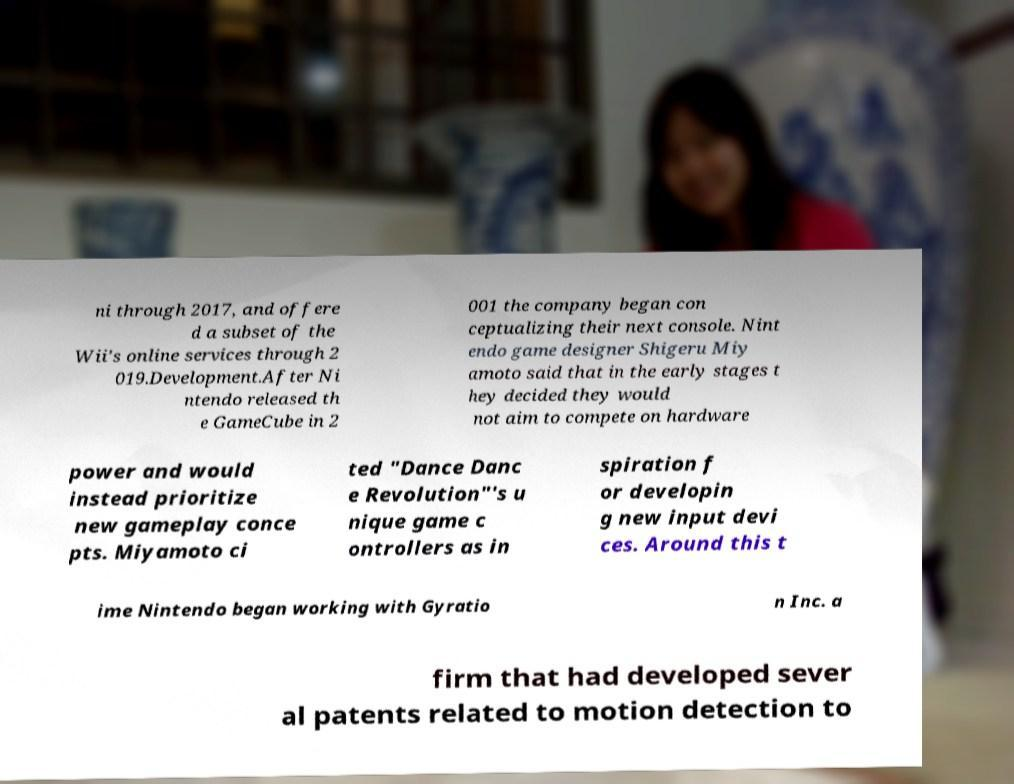There's text embedded in this image that I need extracted. Can you transcribe it verbatim? ni through 2017, and offere d a subset of the Wii's online services through 2 019.Development.After Ni ntendo released th e GameCube in 2 001 the company began con ceptualizing their next console. Nint endo game designer Shigeru Miy amoto said that in the early stages t hey decided they would not aim to compete on hardware power and would instead prioritize new gameplay conce pts. Miyamoto ci ted "Dance Danc e Revolution"'s u nique game c ontrollers as in spiration f or developin g new input devi ces. Around this t ime Nintendo began working with Gyratio n Inc. a firm that had developed sever al patents related to motion detection to 